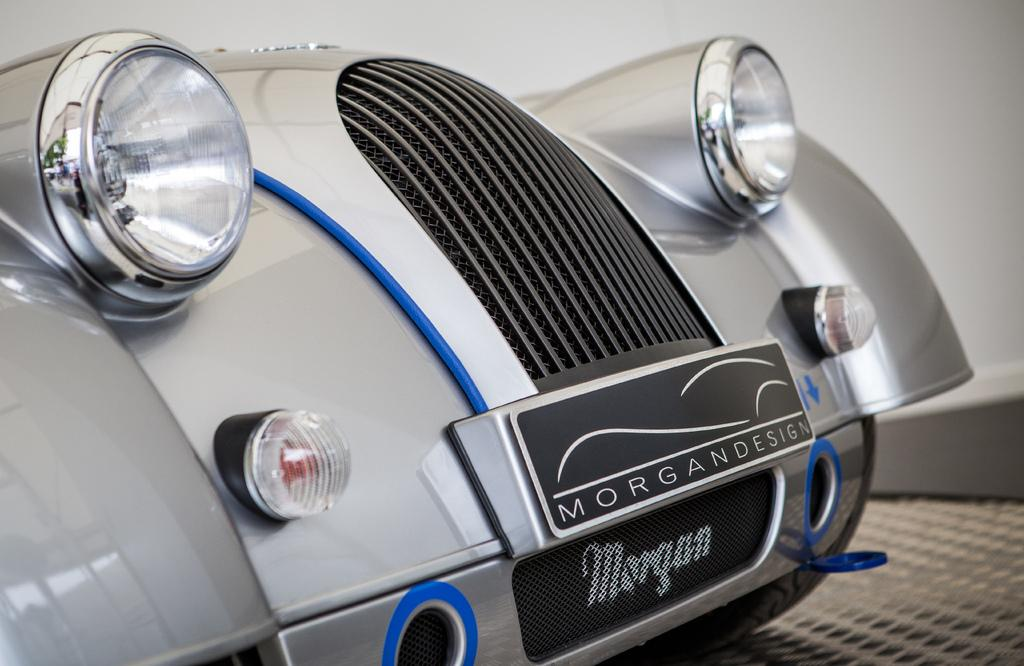What is the main subject of the image? The main subject of the image is a car. Which part of the car can be seen in the image? The front part of the car is visible in the image. Where is the car located in the image? The car is on a path in the image. Can you see a robin perched on the car's hood in the image? No, there is no robin present in the image. What type of wool is used to make the car's tires in the image? The car's tires are not made of wool; they are made of rubber or a similar material. 